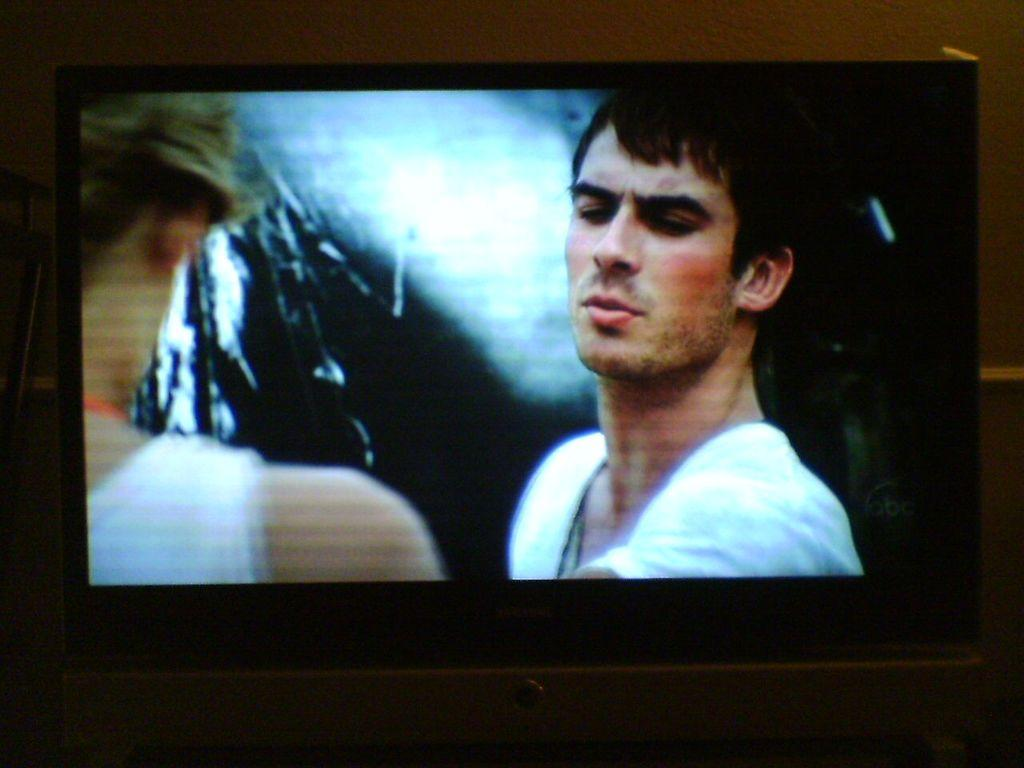What is the main object in the image? There is a television in the image. What can be seen on the television screen? Two people are visible on the television screen. What are the people wearing? Both people are wearing white dresses. How would you describe the lighting in the image? The image appears to be slightly dark. What decision did the doctor make in the image? There is no doctor or decision-making process depicted in the image; it features a television with two people wearing white dresses. 